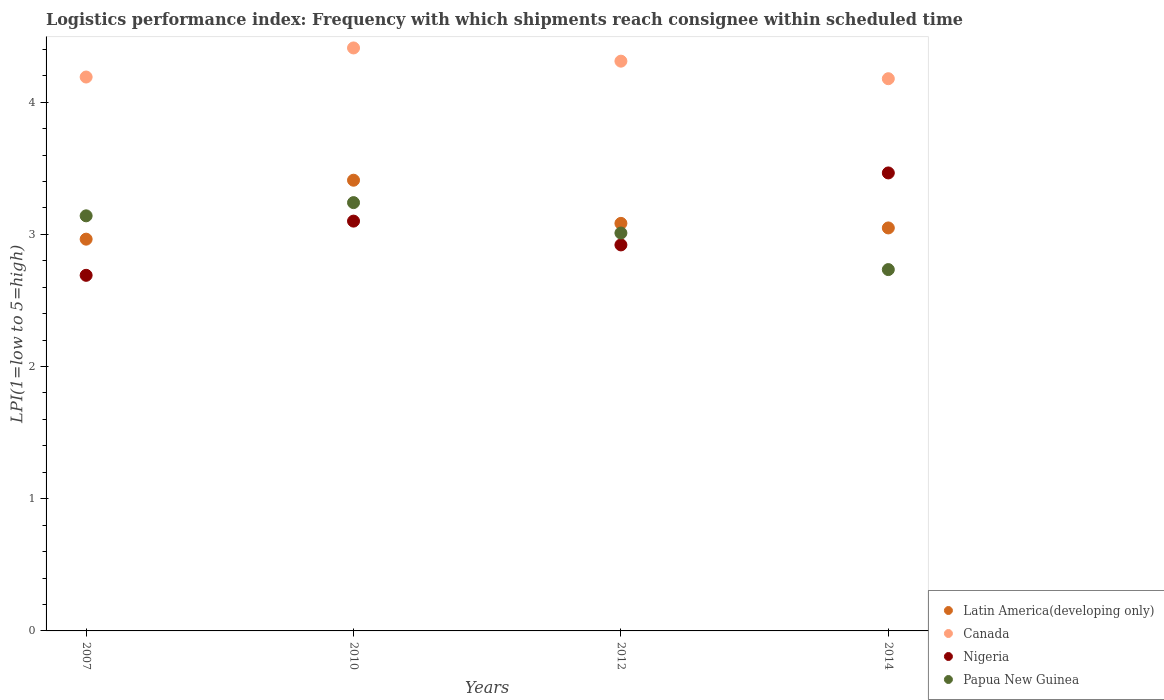How many different coloured dotlines are there?
Offer a terse response. 4. What is the logistics performance index in Latin America(developing only) in 2007?
Your response must be concise. 2.96. Across all years, what is the maximum logistics performance index in Papua New Guinea?
Provide a short and direct response. 3.24. Across all years, what is the minimum logistics performance index in Latin America(developing only)?
Your answer should be very brief. 2.96. In which year was the logistics performance index in Papua New Guinea minimum?
Your answer should be very brief. 2014. What is the total logistics performance index in Latin America(developing only) in the graph?
Keep it short and to the point. 12.5. What is the difference between the logistics performance index in Papua New Guinea in 2012 and that in 2014?
Your answer should be compact. 0.28. What is the difference between the logistics performance index in Nigeria in 2014 and the logistics performance index in Latin America(developing only) in 2012?
Offer a very short reply. 0.38. What is the average logistics performance index in Papua New Guinea per year?
Ensure brevity in your answer.  3.03. In the year 2007, what is the difference between the logistics performance index in Canada and logistics performance index in Latin America(developing only)?
Ensure brevity in your answer.  1.23. What is the ratio of the logistics performance index in Latin America(developing only) in 2007 to that in 2012?
Your response must be concise. 0.96. Is the logistics performance index in Papua New Guinea in 2010 less than that in 2012?
Offer a very short reply. No. What is the difference between the highest and the second highest logistics performance index in Canada?
Make the answer very short. 0.1. What is the difference between the highest and the lowest logistics performance index in Latin America(developing only)?
Make the answer very short. 0.45. Is the sum of the logistics performance index in Canada in 2010 and 2012 greater than the maximum logistics performance index in Latin America(developing only) across all years?
Your answer should be compact. Yes. Is it the case that in every year, the sum of the logistics performance index in Papua New Guinea and logistics performance index in Canada  is greater than the logistics performance index in Nigeria?
Provide a short and direct response. Yes. Is the logistics performance index in Papua New Guinea strictly less than the logistics performance index in Canada over the years?
Give a very brief answer. Yes. How many years are there in the graph?
Your answer should be compact. 4. What is the difference between two consecutive major ticks on the Y-axis?
Your answer should be compact. 1. Does the graph contain any zero values?
Ensure brevity in your answer.  No. Does the graph contain grids?
Keep it short and to the point. No. Where does the legend appear in the graph?
Keep it short and to the point. Bottom right. How many legend labels are there?
Your answer should be very brief. 4. How are the legend labels stacked?
Your answer should be very brief. Vertical. What is the title of the graph?
Your answer should be compact. Logistics performance index: Frequency with which shipments reach consignee within scheduled time. What is the label or title of the Y-axis?
Provide a succinct answer. LPI(1=low to 5=high). What is the LPI(1=low to 5=high) of Latin America(developing only) in 2007?
Your answer should be compact. 2.96. What is the LPI(1=low to 5=high) of Canada in 2007?
Keep it short and to the point. 4.19. What is the LPI(1=low to 5=high) in Nigeria in 2007?
Make the answer very short. 2.69. What is the LPI(1=low to 5=high) of Papua New Guinea in 2007?
Your answer should be very brief. 3.14. What is the LPI(1=low to 5=high) of Latin America(developing only) in 2010?
Your answer should be compact. 3.41. What is the LPI(1=low to 5=high) in Canada in 2010?
Provide a succinct answer. 4.41. What is the LPI(1=low to 5=high) in Nigeria in 2010?
Your answer should be compact. 3.1. What is the LPI(1=low to 5=high) of Papua New Guinea in 2010?
Make the answer very short. 3.24. What is the LPI(1=low to 5=high) in Latin America(developing only) in 2012?
Give a very brief answer. 3.08. What is the LPI(1=low to 5=high) of Canada in 2012?
Give a very brief answer. 4.31. What is the LPI(1=low to 5=high) in Nigeria in 2012?
Your answer should be very brief. 2.92. What is the LPI(1=low to 5=high) in Papua New Guinea in 2012?
Your answer should be compact. 3.01. What is the LPI(1=low to 5=high) in Latin America(developing only) in 2014?
Offer a terse response. 3.05. What is the LPI(1=low to 5=high) of Canada in 2014?
Keep it short and to the point. 4.18. What is the LPI(1=low to 5=high) of Nigeria in 2014?
Offer a very short reply. 3.46. What is the LPI(1=low to 5=high) of Papua New Guinea in 2014?
Keep it short and to the point. 2.73. Across all years, what is the maximum LPI(1=low to 5=high) of Latin America(developing only)?
Keep it short and to the point. 3.41. Across all years, what is the maximum LPI(1=low to 5=high) of Canada?
Make the answer very short. 4.41. Across all years, what is the maximum LPI(1=low to 5=high) in Nigeria?
Offer a very short reply. 3.46. Across all years, what is the maximum LPI(1=low to 5=high) of Papua New Guinea?
Your answer should be very brief. 3.24. Across all years, what is the minimum LPI(1=low to 5=high) of Latin America(developing only)?
Give a very brief answer. 2.96. Across all years, what is the minimum LPI(1=low to 5=high) in Canada?
Keep it short and to the point. 4.18. Across all years, what is the minimum LPI(1=low to 5=high) in Nigeria?
Ensure brevity in your answer.  2.69. Across all years, what is the minimum LPI(1=low to 5=high) in Papua New Guinea?
Your answer should be very brief. 2.73. What is the total LPI(1=low to 5=high) in Latin America(developing only) in the graph?
Give a very brief answer. 12.5. What is the total LPI(1=low to 5=high) of Canada in the graph?
Provide a short and direct response. 17.09. What is the total LPI(1=low to 5=high) of Nigeria in the graph?
Provide a short and direct response. 12.17. What is the total LPI(1=low to 5=high) of Papua New Guinea in the graph?
Offer a very short reply. 12.12. What is the difference between the LPI(1=low to 5=high) in Latin America(developing only) in 2007 and that in 2010?
Your response must be concise. -0.45. What is the difference between the LPI(1=low to 5=high) in Canada in 2007 and that in 2010?
Your response must be concise. -0.22. What is the difference between the LPI(1=low to 5=high) in Nigeria in 2007 and that in 2010?
Your response must be concise. -0.41. What is the difference between the LPI(1=low to 5=high) in Papua New Guinea in 2007 and that in 2010?
Give a very brief answer. -0.1. What is the difference between the LPI(1=low to 5=high) of Latin America(developing only) in 2007 and that in 2012?
Ensure brevity in your answer.  -0.12. What is the difference between the LPI(1=low to 5=high) of Canada in 2007 and that in 2012?
Give a very brief answer. -0.12. What is the difference between the LPI(1=low to 5=high) of Nigeria in 2007 and that in 2012?
Your answer should be very brief. -0.23. What is the difference between the LPI(1=low to 5=high) in Papua New Guinea in 2007 and that in 2012?
Make the answer very short. 0.13. What is the difference between the LPI(1=low to 5=high) of Latin America(developing only) in 2007 and that in 2014?
Offer a very short reply. -0.08. What is the difference between the LPI(1=low to 5=high) of Canada in 2007 and that in 2014?
Provide a succinct answer. 0.01. What is the difference between the LPI(1=low to 5=high) of Nigeria in 2007 and that in 2014?
Give a very brief answer. -0.77. What is the difference between the LPI(1=low to 5=high) of Papua New Guinea in 2007 and that in 2014?
Your response must be concise. 0.41. What is the difference between the LPI(1=low to 5=high) of Latin America(developing only) in 2010 and that in 2012?
Make the answer very short. 0.33. What is the difference between the LPI(1=low to 5=high) of Canada in 2010 and that in 2012?
Your response must be concise. 0.1. What is the difference between the LPI(1=low to 5=high) of Nigeria in 2010 and that in 2012?
Ensure brevity in your answer.  0.18. What is the difference between the LPI(1=low to 5=high) in Papua New Guinea in 2010 and that in 2012?
Ensure brevity in your answer.  0.23. What is the difference between the LPI(1=low to 5=high) of Latin America(developing only) in 2010 and that in 2014?
Ensure brevity in your answer.  0.36. What is the difference between the LPI(1=low to 5=high) of Canada in 2010 and that in 2014?
Ensure brevity in your answer.  0.23. What is the difference between the LPI(1=low to 5=high) in Nigeria in 2010 and that in 2014?
Make the answer very short. -0.36. What is the difference between the LPI(1=low to 5=high) in Papua New Guinea in 2010 and that in 2014?
Offer a very short reply. 0.51. What is the difference between the LPI(1=low to 5=high) of Latin America(developing only) in 2012 and that in 2014?
Offer a very short reply. 0.03. What is the difference between the LPI(1=low to 5=high) in Canada in 2012 and that in 2014?
Ensure brevity in your answer.  0.13. What is the difference between the LPI(1=low to 5=high) of Nigeria in 2012 and that in 2014?
Your answer should be compact. -0.54. What is the difference between the LPI(1=low to 5=high) in Papua New Guinea in 2012 and that in 2014?
Provide a succinct answer. 0.28. What is the difference between the LPI(1=low to 5=high) in Latin America(developing only) in 2007 and the LPI(1=low to 5=high) in Canada in 2010?
Your answer should be compact. -1.45. What is the difference between the LPI(1=low to 5=high) of Latin America(developing only) in 2007 and the LPI(1=low to 5=high) of Nigeria in 2010?
Make the answer very short. -0.14. What is the difference between the LPI(1=low to 5=high) of Latin America(developing only) in 2007 and the LPI(1=low to 5=high) of Papua New Guinea in 2010?
Keep it short and to the point. -0.28. What is the difference between the LPI(1=low to 5=high) in Canada in 2007 and the LPI(1=low to 5=high) in Nigeria in 2010?
Your response must be concise. 1.09. What is the difference between the LPI(1=low to 5=high) of Canada in 2007 and the LPI(1=low to 5=high) of Papua New Guinea in 2010?
Offer a very short reply. 0.95. What is the difference between the LPI(1=low to 5=high) of Nigeria in 2007 and the LPI(1=low to 5=high) of Papua New Guinea in 2010?
Offer a terse response. -0.55. What is the difference between the LPI(1=low to 5=high) in Latin America(developing only) in 2007 and the LPI(1=low to 5=high) in Canada in 2012?
Provide a succinct answer. -1.35. What is the difference between the LPI(1=low to 5=high) of Latin America(developing only) in 2007 and the LPI(1=low to 5=high) of Nigeria in 2012?
Provide a short and direct response. 0.04. What is the difference between the LPI(1=low to 5=high) in Latin America(developing only) in 2007 and the LPI(1=low to 5=high) in Papua New Guinea in 2012?
Offer a very short reply. -0.05. What is the difference between the LPI(1=low to 5=high) of Canada in 2007 and the LPI(1=low to 5=high) of Nigeria in 2012?
Ensure brevity in your answer.  1.27. What is the difference between the LPI(1=low to 5=high) in Canada in 2007 and the LPI(1=low to 5=high) in Papua New Guinea in 2012?
Keep it short and to the point. 1.18. What is the difference between the LPI(1=low to 5=high) in Nigeria in 2007 and the LPI(1=low to 5=high) in Papua New Guinea in 2012?
Make the answer very short. -0.32. What is the difference between the LPI(1=low to 5=high) in Latin America(developing only) in 2007 and the LPI(1=low to 5=high) in Canada in 2014?
Your response must be concise. -1.21. What is the difference between the LPI(1=low to 5=high) in Latin America(developing only) in 2007 and the LPI(1=low to 5=high) in Nigeria in 2014?
Make the answer very short. -0.5. What is the difference between the LPI(1=low to 5=high) of Latin America(developing only) in 2007 and the LPI(1=low to 5=high) of Papua New Guinea in 2014?
Your answer should be compact. 0.23. What is the difference between the LPI(1=low to 5=high) in Canada in 2007 and the LPI(1=low to 5=high) in Nigeria in 2014?
Your answer should be very brief. 0.73. What is the difference between the LPI(1=low to 5=high) in Canada in 2007 and the LPI(1=low to 5=high) in Papua New Guinea in 2014?
Your response must be concise. 1.46. What is the difference between the LPI(1=low to 5=high) in Nigeria in 2007 and the LPI(1=low to 5=high) in Papua New Guinea in 2014?
Offer a very short reply. -0.04. What is the difference between the LPI(1=low to 5=high) in Latin America(developing only) in 2010 and the LPI(1=low to 5=high) in Canada in 2012?
Keep it short and to the point. -0.9. What is the difference between the LPI(1=low to 5=high) in Latin America(developing only) in 2010 and the LPI(1=low to 5=high) in Nigeria in 2012?
Ensure brevity in your answer.  0.49. What is the difference between the LPI(1=low to 5=high) in Latin America(developing only) in 2010 and the LPI(1=low to 5=high) in Papua New Guinea in 2012?
Provide a short and direct response. 0.4. What is the difference between the LPI(1=low to 5=high) in Canada in 2010 and the LPI(1=low to 5=high) in Nigeria in 2012?
Provide a succinct answer. 1.49. What is the difference between the LPI(1=low to 5=high) in Canada in 2010 and the LPI(1=low to 5=high) in Papua New Guinea in 2012?
Offer a terse response. 1.4. What is the difference between the LPI(1=low to 5=high) of Nigeria in 2010 and the LPI(1=low to 5=high) of Papua New Guinea in 2012?
Give a very brief answer. 0.09. What is the difference between the LPI(1=low to 5=high) of Latin America(developing only) in 2010 and the LPI(1=low to 5=high) of Canada in 2014?
Provide a short and direct response. -0.77. What is the difference between the LPI(1=low to 5=high) of Latin America(developing only) in 2010 and the LPI(1=low to 5=high) of Nigeria in 2014?
Give a very brief answer. -0.06. What is the difference between the LPI(1=low to 5=high) of Latin America(developing only) in 2010 and the LPI(1=low to 5=high) of Papua New Guinea in 2014?
Offer a very short reply. 0.68. What is the difference between the LPI(1=low to 5=high) in Canada in 2010 and the LPI(1=low to 5=high) in Nigeria in 2014?
Your response must be concise. 0.95. What is the difference between the LPI(1=low to 5=high) of Canada in 2010 and the LPI(1=low to 5=high) of Papua New Guinea in 2014?
Offer a terse response. 1.68. What is the difference between the LPI(1=low to 5=high) in Nigeria in 2010 and the LPI(1=low to 5=high) in Papua New Guinea in 2014?
Keep it short and to the point. 0.37. What is the difference between the LPI(1=low to 5=high) of Latin America(developing only) in 2012 and the LPI(1=low to 5=high) of Canada in 2014?
Give a very brief answer. -1.09. What is the difference between the LPI(1=low to 5=high) in Latin America(developing only) in 2012 and the LPI(1=low to 5=high) in Nigeria in 2014?
Ensure brevity in your answer.  -0.38. What is the difference between the LPI(1=low to 5=high) in Latin America(developing only) in 2012 and the LPI(1=low to 5=high) in Papua New Guinea in 2014?
Offer a terse response. 0.35. What is the difference between the LPI(1=low to 5=high) in Canada in 2012 and the LPI(1=low to 5=high) in Nigeria in 2014?
Make the answer very short. 0.85. What is the difference between the LPI(1=low to 5=high) of Canada in 2012 and the LPI(1=low to 5=high) of Papua New Guinea in 2014?
Keep it short and to the point. 1.58. What is the difference between the LPI(1=low to 5=high) in Nigeria in 2012 and the LPI(1=low to 5=high) in Papua New Guinea in 2014?
Offer a terse response. 0.19. What is the average LPI(1=low to 5=high) of Latin America(developing only) per year?
Provide a short and direct response. 3.13. What is the average LPI(1=low to 5=high) of Canada per year?
Offer a terse response. 4.27. What is the average LPI(1=low to 5=high) in Nigeria per year?
Keep it short and to the point. 3.04. What is the average LPI(1=low to 5=high) of Papua New Guinea per year?
Your response must be concise. 3.03. In the year 2007, what is the difference between the LPI(1=low to 5=high) of Latin America(developing only) and LPI(1=low to 5=high) of Canada?
Provide a short and direct response. -1.23. In the year 2007, what is the difference between the LPI(1=low to 5=high) in Latin America(developing only) and LPI(1=low to 5=high) in Nigeria?
Your answer should be compact. 0.27. In the year 2007, what is the difference between the LPI(1=low to 5=high) in Latin America(developing only) and LPI(1=low to 5=high) in Papua New Guinea?
Give a very brief answer. -0.18. In the year 2007, what is the difference between the LPI(1=low to 5=high) of Nigeria and LPI(1=low to 5=high) of Papua New Guinea?
Offer a terse response. -0.45. In the year 2010, what is the difference between the LPI(1=low to 5=high) in Latin America(developing only) and LPI(1=low to 5=high) in Canada?
Provide a short and direct response. -1. In the year 2010, what is the difference between the LPI(1=low to 5=high) of Latin America(developing only) and LPI(1=low to 5=high) of Nigeria?
Ensure brevity in your answer.  0.31. In the year 2010, what is the difference between the LPI(1=low to 5=high) of Latin America(developing only) and LPI(1=low to 5=high) of Papua New Guinea?
Your answer should be very brief. 0.17. In the year 2010, what is the difference between the LPI(1=low to 5=high) of Canada and LPI(1=low to 5=high) of Nigeria?
Provide a succinct answer. 1.31. In the year 2010, what is the difference between the LPI(1=low to 5=high) of Canada and LPI(1=low to 5=high) of Papua New Guinea?
Your answer should be compact. 1.17. In the year 2010, what is the difference between the LPI(1=low to 5=high) of Nigeria and LPI(1=low to 5=high) of Papua New Guinea?
Make the answer very short. -0.14. In the year 2012, what is the difference between the LPI(1=low to 5=high) of Latin America(developing only) and LPI(1=low to 5=high) of Canada?
Your response must be concise. -1.23. In the year 2012, what is the difference between the LPI(1=low to 5=high) of Latin America(developing only) and LPI(1=low to 5=high) of Nigeria?
Offer a very short reply. 0.16. In the year 2012, what is the difference between the LPI(1=low to 5=high) in Latin America(developing only) and LPI(1=low to 5=high) in Papua New Guinea?
Your answer should be very brief. 0.07. In the year 2012, what is the difference between the LPI(1=low to 5=high) in Canada and LPI(1=low to 5=high) in Nigeria?
Provide a short and direct response. 1.39. In the year 2012, what is the difference between the LPI(1=low to 5=high) of Canada and LPI(1=low to 5=high) of Papua New Guinea?
Your answer should be compact. 1.3. In the year 2012, what is the difference between the LPI(1=low to 5=high) of Nigeria and LPI(1=low to 5=high) of Papua New Guinea?
Ensure brevity in your answer.  -0.09. In the year 2014, what is the difference between the LPI(1=low to 5=high) of Latin America(developing only) and LPI(1=low to 5=high) of Canada?
Provide a succinct answer. -1.13. In the year 2014, what is the difference between the LPI(1=low to 5=high) in Latin America(developing only) and LPI(1=low to 5=high) in Nigeria?
Your answer should be very brief. -0.42. In the year 2014, what is the difference between the LPI(1=low to 5=high) in Latin America(developing only) and LPI(1=low to 5=high) in Papua New Guinea?
Make the answer very short. 0.32. In the year 2014, what is the difference between the LPI(1=low to 5=high) of Canada and LPI(1=low to 5=high) of Nigeria?
Your response must be concise. 0.71. In the year 2014, what is the difference between the LPI(1=low to 5=high) in Canada and LPI(1=low to 5=high) in Papua New Guinea?
Your response must be concise. 1.44. In the year 2014, what is the difference between the LPI(1=low to 5=high) in Nigeria and LPI(1=low to 5=high) in Papua New Guinea?
Give a very brief answer. 0.73. What is the ratio of the LPI(1=low to 5=high) of Latin America(developing only) in 2007 to that in 2010?
Keep it short and to the point. 0.87. What is the ratio of the LPI(1=low to 5=high) of Canada in 2007 to that in 2010?
Your answer should be compact. 0.95. What is the ratio of the LPI(1=low to 5=high) in Nigeria in 2007 to that in 2010?
Give a very brief answer. 0.87. What is the ratio of the LPI(1=low to 5=high) of Papua New Guinea in 2007 to that in 2010?
Your answer should be compact. 0.97. What is the ratio of the LPI(1=low to 5=high) in Latin America(developing only) in 2007 to that in 2012?
Your answer should be very brief. 0.96. What is the ratio of the LPI(1=low to 5=high) of Canada in 2007 to that in 2012?
Make the answer very short. 0.97. What is the ratio of the LPI(1=low to 5=high) in Nigeria in 2007 to that in 2012?
Provide a succinct answer. 0.92. What is the ratio of the LPI(1=low to 5=high) in Papua New Guinea in 2007 to that in 2012?
Offer a very short reply. 1.04. What is the ratio of the LPI(1=low to 5=high) in Latin America(developing only) in 2007 to that in 2014?
Provide a succinct answer. 0.97. What is the ratio of the LPI(1=low to 5=high) in Canada in 2007 to that in 2014?
Your answer should be very brief. 1. What is the ratio of the LPI(1=low to 5=high) in Nigeria in 2007 to that in 2014?
Your answer should be compact. 0.78. What is the ratio of the LPI(1=low to 5=high) of Papua New Guinea in 2007 to that in 2014?
Provide a succinct answer. 1.15. What is the ratio of the LPI(1=low to 5=high) of Latin America(developing only) in 2010 to that in 2012?
Give a very brief answer. 1.11. What is the ratio of the LPI(1=low to 5=high) in Canada in 2010 to that in 2012?
Offer a very short reply. 1.02. What is the ratio of the LPI(1=low to 5=high) of Nigeria in 2010 to that in 2012?
Offer a very short reply. 1.06. What is the ratio of the LPI(1=low to 5=high) in Papua New Guinea in 2010 to that in 2012?
Give a very brief answer. 1.08. What is the ratio of the LPI(1=low to 5=high) in Latin America(developing only) in 2010 to that in 2014?
Your response must be concise. 1.12. What is the ratio of the LPI(1=low to 5=high) in Canada in 2010 to that in 2014?
Make the answer very short. 1.06. What is the ratio of the LPI(1=low to 5=high) in Nigeria in 2010 to that in 2014?
Your answer should be compact. 0.89. What is the ratio of the LPI(1=low to 5=high) in Papua New Guinea in 2010 to that in 2014?
Ensure brevity in your answer.  1.19. What is the ratio of the LPI(1=low to 5=high) in Latin America(developing only) in 2012 to that in 2014?
Provide a short and direct response. 1.01. What is the ratio of the LPI(1=low to 5=high) in Canada in 2012 to that in 2014?
Your answer should be very brief. 1.03. What is the ratio of the LPI(1=low to 5=high) in Nigeria in 2012 to that in 2014?
Make the answer very short. 0.84. What is the ratio of the LPI(1=low to 5=high) of Papua New Guinea in 2012 to that in 2014?
Your response must be concise. 1.1. What is the difference between the highest and the second highest LPI(1=low to 5=high) of Latin America(developing only)?
Your answer should be very brief. 0.33. What is the difference between the highest and the second highest LPI(1=low to 5=high) of Canada?
Make the answer very short. 0.1. What is the difference between the highest and the second highest LPI(1=low to 5=high) in Nigeria?
Ensure brevity in your answer.  0.36. What is the difference between the highest and the lowest LPI(1=low to 5=high) in Latin America(developing only)?
Offer a terse response. 0.45. What is the difference between the highest and the lowest LPI(1=low to 5=high) of Canada?
Offer a terse response. 0.23. What is the difference between the highest and the lowest LPI(1=low to 5=high) of Nigeria?
Your answer should be very brief. 0.77. What is the difference between the highest and the lowest LPI(1=low to 5=high) in Papua New Guinea?
Make the answer very short. 0.51. 